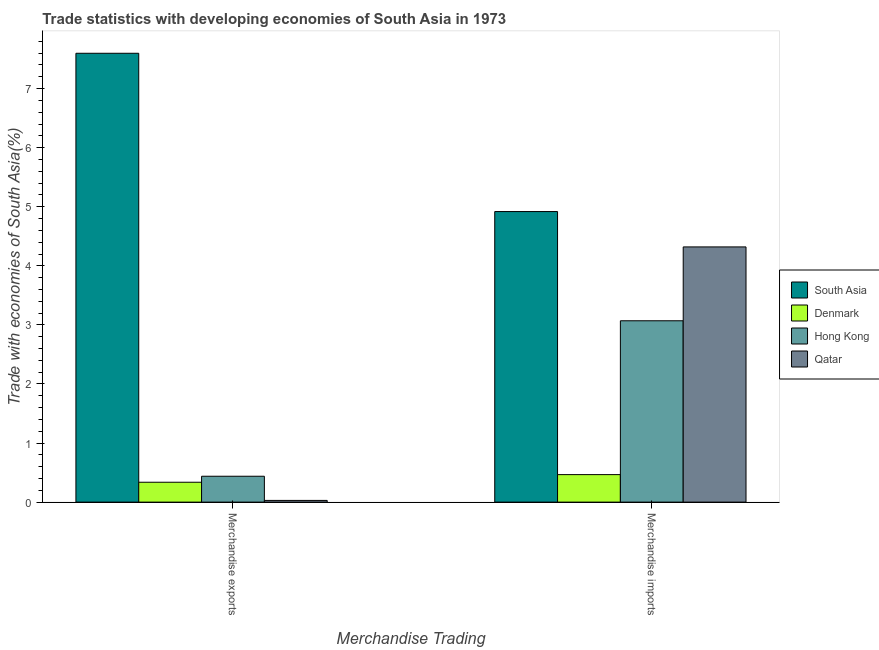How many different coloured bars are there?
Your answer should be compact. 4. Are the number of bars per tick equal to the number of legend labels?
Provide a succinct answer. Yes. Are the number of bars on each tick of the X-axis equal?
Your answer should be very brief. Yes. How many bars are there on the 1st tick from the left?
Offer a very short reply. 4. How many bars are there on the 1st tick from the right?
Your answer should be compact. 4. What is the merchandise imports in Qatar?
Your answer should be very brief. 4.32. Across all countries, what is the maximum merchandise exports?
Make the answer very short. 7.6. Across all countries, what is the minimum merchandise imports?
Provide a short and direct response. 0.47. In which country was the merchandise exports maximum?
Give a very brief answer. South Asia. In which country was the merchandise imports minimum?
Give a very brief answer. Denmark. What is the total merchandise exports in the graph?
Give a very brief answer. 8.4. What is the difference between the merchandise imports in Denmark and that in South Asia?
Provide a succinct answer. -4.45. What is the difference between the merchandise imports in Hong Kong and the merchandise exports in Denmark?
Keep it short and to the point. 2.73. What is the average merchandise imports per country?
Provide a short and direct response. 3.19. What is the difference between the merchandise imports and merchandise exports in South Asia?
Your answer should be compact. -2.68. What is the ratio of the merchandise exports in Denmark to that in South Asia?
Ensure brevity in your answer.  0.04. In how many countries, is the merchandise imports greater than the average merchandise imports taken over all countries?
Your answer should be compact. 2. What does the 2nd bar from the left in Merchandise imports represents?
Your answer should be very brief. Denmark. How many countries are there in the graph?
Ensure brevity in your answer.  4. What is the difference between two consecutive major ticks on the Y-axis?
Offer a very short reply. 1. Are the values on the major ticks of Y-axis written in scientific E-notation?
Keep it short and to the point. No. Where does the legend appear in the graph?
Provide a succinct answer. Center right. How are the legend labels stacked?
Your response must be concise. Vertical. What is the title of the graph?
Offer a very short reply. Trade statistics with developing economies of South Asia in 1973. What is the label or title of the X-axis?
Keep it short and to the point. Merchandise Trading. What is the label or title of the Y-axis?
Ensure brevity in your answer.  Trade with economies of South Asia(%). What is the Trade with economies of South Asia(%) in South Asia in Merchandise exports?
Provide a short and direct response. 7.6. What is the Trade with economies of South Asia(%) in Denmark in Merchandise exports?
Offer a very short reply. 0.34. What is the Trade with economies of South Asia(%) of Hong Kong in Merchandise exports?
Your answer should be compact. 0.44. What is the Trade with economies of South Asia(%) of Qatar in Merchandise exports?
Your response must be concise. 0.03. What is the Trade with economies of South Asia(%) in South Asia in Merchandise imports?
Provide a succinct answer. 4.92. What is the Trade with economies of South Asia(%) in Denmark in Merchandise imports?
Ensure brevity in your answer.  0.47. What is the Trade with economies of South Asia(%) of Hong Kong in Merchandise imports?
Offer a terse response. 3.07. What is the Trade with economies of South Asia(%) of Qatar in Merchandise imports?
Provide a short and direct response. 4.32. Across all Merchandise Trading, what is the maximum Trade with economies of South Asia(%) in South Asia?
Your answer should be very brief. 7.6. Across all Merchandise Trading, what is the maximum Trade with economies of South Asia(%) of Denmark?
Provide a short and direct response. 0.47. Across all Merchandise Trading, what is the maximum Trade with economies of South Asia(%) of Hong Kong?
Keep it short and to the point. 3.07. Across all Merchandise Trading, what is the maximum Trade with economies of South Asia(%) of Qatar?
Make the answer very short. 4.32. Across all Merchandise Trading, what is the minimum Trade with economies of South Asia(%) in South Asia?
Offer a very short reply. 4.92. Across all Merchandise Trading, what is the minimum Trade with economies of South Asia(%) in Denmark?
Your answer should be compact. 0.34. Across all Merchandise Trading, what is the minimum Trade with economies of South Asia(%) in Hong Kong?
Provide a short and direct response. 0.44. Across all Merchandise Trading, what is the minimum Trade with economies of South Asia(%) of Qatar?
Offer a terse response. 0.03. What is the total Trade with economies of South Asia(%) of South Asia in the graph?
Ensure brevity in your answer.  12.52. What is the total Trade with economies of South Asia(%) of Denmark in the graph?
Give a very brief answer. 0.8. What is the total Trade with economies of South Asia(%) of Hong Kong in the graph?
Provide a succinct answer. 3.51. What is the total Trade with economies of South Asia(%) of Qatar in the graph?
Provide a succinct answer. 4.35. What is the difference between the Trade with economies of South Asia(%) in South Asia in Merchandise exports and that in Merchandise imports?
Your response must be concise. 2.68. What is the difference between the Trade with economies of South Asia(%) of Denmark in Merchandise exports and that in Merchandise imports?
Give a very brief answer. -0.13. What is the difference between the Trade with economies of South Asia(%) in Hong Kong in Merchandise exports and that in Merchandise imports?
Keep it short and to the point. -2.63. What is the difference between the Trade with economies of South Asia(%) of Qatar in Merchandise exports and that in Merchandise imports?
Give a very brief answer. -4.29. What is the difference between the Trade with economies of South Asia(%) of South Asia in Merchandise exports and the Trade with economies of South Asia(%) of Denmark in Merchandise imports?
Offer a terse response. 7.13. What is the difference between the Trade with economies of South Asia(%) in South Asia in Merchandise exports and the Trade with economies of South Asia(%) in Hong Kong in Merchandise imports?
Give a very brief answer. 4.53. What is the difference between the Trade with economies of South Asia(%) of South Asia in Merchandise exports and the Trade with economies of South Asia(%) of Qatar in Merchandise imports?
Provide a short and direct response. 3.28. What is the difference between the Trade with economies of South Asia(%) of Denmark in Merchandise exports and the Trade with economies of South Asia(%) of Hong Kong in Merchandise imports?
Provide a succinct answer. -2.73. What is the difference between the Trade with economies of South Asia(%) of Denmark in Merchandise exports and the Trade with economies of South Asia(%) of Qatar in Merchandise imports?
Your answer should be very brief. -3.98. What is the difference between the Trade with economies of South Asia(%) of Hong Kong in Merchandise exports and the Trade with economies of South Asia(%) of Qatar in Merchandise imports?
Your answer should be compact. -3.88. What is the average Trade with economies of South Asia(%) of South Asia per Merchandise Trading?
Provide a succinct answer. 6.26. What is the average Trade with economies of South Asia(%) in Denmark per Merchandise Trading?
Keep it short and to the point. 0.4. What is the average Trade with economies of South Asia(%) in Hong Kong per Merchandise Trading?
Offer a terse response. 1.75. What is the average Trade with economies of South Asia(%) in Qatar per Merchandise Trading?
Offer a terse response. 2.17. What is the difference between the Trade with economies of South Asia(%) of South Asia and Trade with economies of South Asia(%) of Denmark in Merchandise exports?
Offer a terse response. 7.26. What is the difference between the Trade with economies of South Asia(%) of South Asia and Trade with economies of South Asia(%) of Hong Kong in Merchandise exports?
Your response must be concise. 7.16. What is the difference between the Trade with economies of South Asia(%) of South Asia and Trade with economies of South Asia(%) of Qatar in Merchandise exports?
Provide a succinct answer. 7.57. What is the difference between the Trade with economies of South Asia(%) of Denmark and Trade with economies of South Asia(%) of Hong Kong in Merchandise exports?
Your response must be concise. -0.1. What is the difference between the Trade with economies of South Asia(%) in Denmark and Trade with economies of South Asia(%) in Qatar in Merchandise exports?
Make the answer very short. 0.31. What is the difference between the Trade with economies of South Asia(%) of Hong Kong and Trade with economies of South Asia(%) of Qatar in Merchandise exports?
Make the answer very short. 0.41. What is the difference between the Trade with economies of South Asia(%) in South Asia and Trade with economies of South Asia(%) in Denmark in Merchandise imports?
Ensure brevity in your answer.  4.45. What is the difference between the Trade with economies of South Asia(%) of South Asia and Trade with economies of South Asia(%) of Hong Kong in Merchandise imports?
Your answer should be compact. 1.85. What is the difference between the Trade with economies of South Asia(%) of South Asia and Trade with economies of South Asia(%) of Qatar in Merchandise imports?
Provide a short and direct response. 0.6. What is the difference between the Trade with economies of South Asia(%) in Denmark and Trade with economies of South Asia(%) in Hong Kong in Merchandise imports?
Your answer should be compact. -2.6. What is the difference between the Trade with economies of South Asia(%) of Denmark and Trade with economies of South Asia(%) of Qatar in Merchandise imports?
Keep it short and to the point. -3.85. What is the difference between the Trade with economies of South Asia(%) of Hong Kong and Trade with economies of South Asia(%) of Qatar in Merchandise imports?
Offer a terse response. -1.25. What is the ratio of the Trade with economies of South Asia(%) in South Asia in Merchandise exports to that in Merchandise imports?
Your answer should be very brief. 1.54. What is the ratio of the Trade with economies of South Asia(%) in Denmark in Merchandise exports to that in Merchandise imports?
Make the answer very short. 0.72. What is the ratio of the Trade with economies of South Asia(%) in Hong Kong in Merchandise exports to that in Merchandise imports?
Provide a succinct answer. 0.14. What is the ratio of the Trade with economies of South Asia(%) of Qatar in Merchandise exports to that in Merchandise imports?
Keep it short and to the point. 0.01. What is the difference between the highest and the second highest Trade with economies of South Asia(%) in South Asia?
Make the answer very short. 2.68. What is the difference between the highest and the second highest Trade with economies of South Asia(%) in Denmark?
Provide a short and direct response. 0.13. What is the difference between the highest and the second highest Trade with economies of South Asia(%) in Hong Kong?
Provide a short and direct response. 2.63. What is the difference between the highest and the second highest Trade with economies of South Asia(%) in Qatar?
Keep it short and to the point. 4.29. What is the difference between the highest and the lowest Trade with economies of South Asia(%) in South Asia?
Offer a very short reply. 2.68. What is the difference between the highest and the lowest Trade with economies of South Asia(%) in Denmark?
Your answer should be very brief. 0.13. What is the difference between the highest and the lowest Trade with economies of South Asia(%) of Hong Kong?
Keep it short and to the point. 2.63. What is the difference between the highest and the lowest Trade with economies of South Asia(%) of Qatar?
Provide a short and direct response. 4.29. 